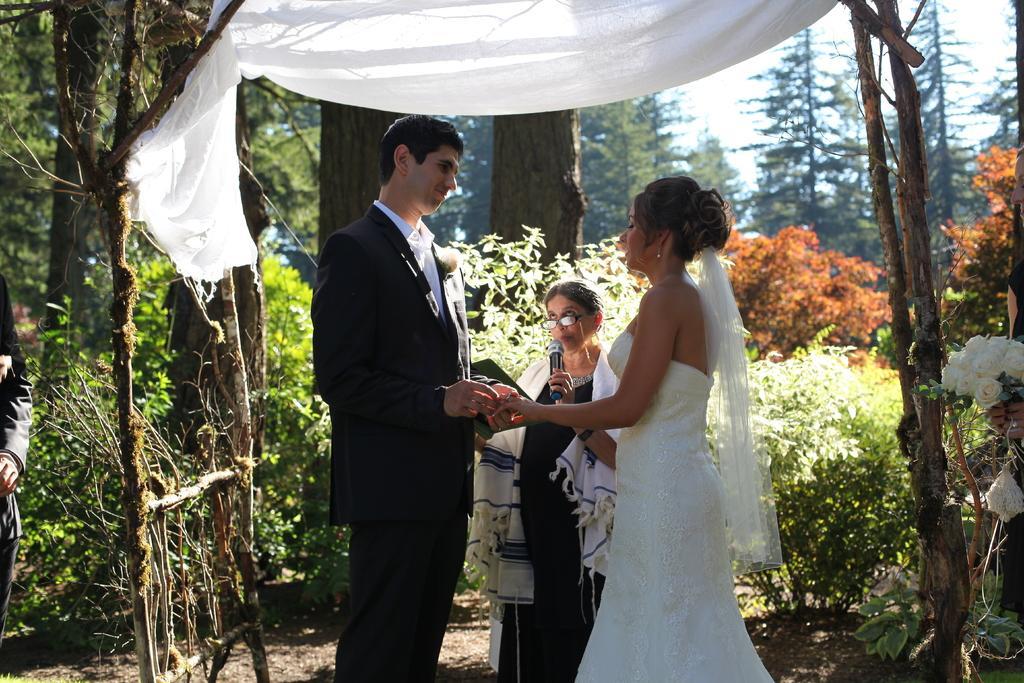Can you describe this image briefly? In this image there are many trees in the image. A person is holding a lady's hand. An old lady standing and holding a microphone and speaking in it. 